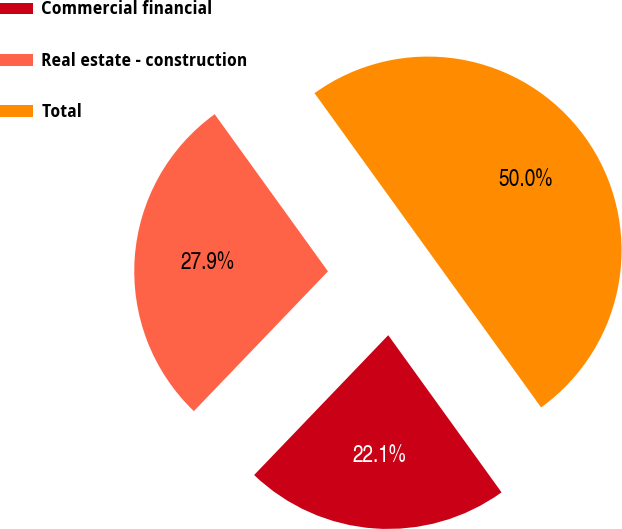Convert chart to OTSL. <chart><loc_0><loc_0><loc_500><loc_500><pie_chart><fcel>Commercial financial<fcel>Real estate - construction<fcel>Total<nl><fcel>22.11%<fcel>27.89%<fcel>50.0%<nl></chart> 